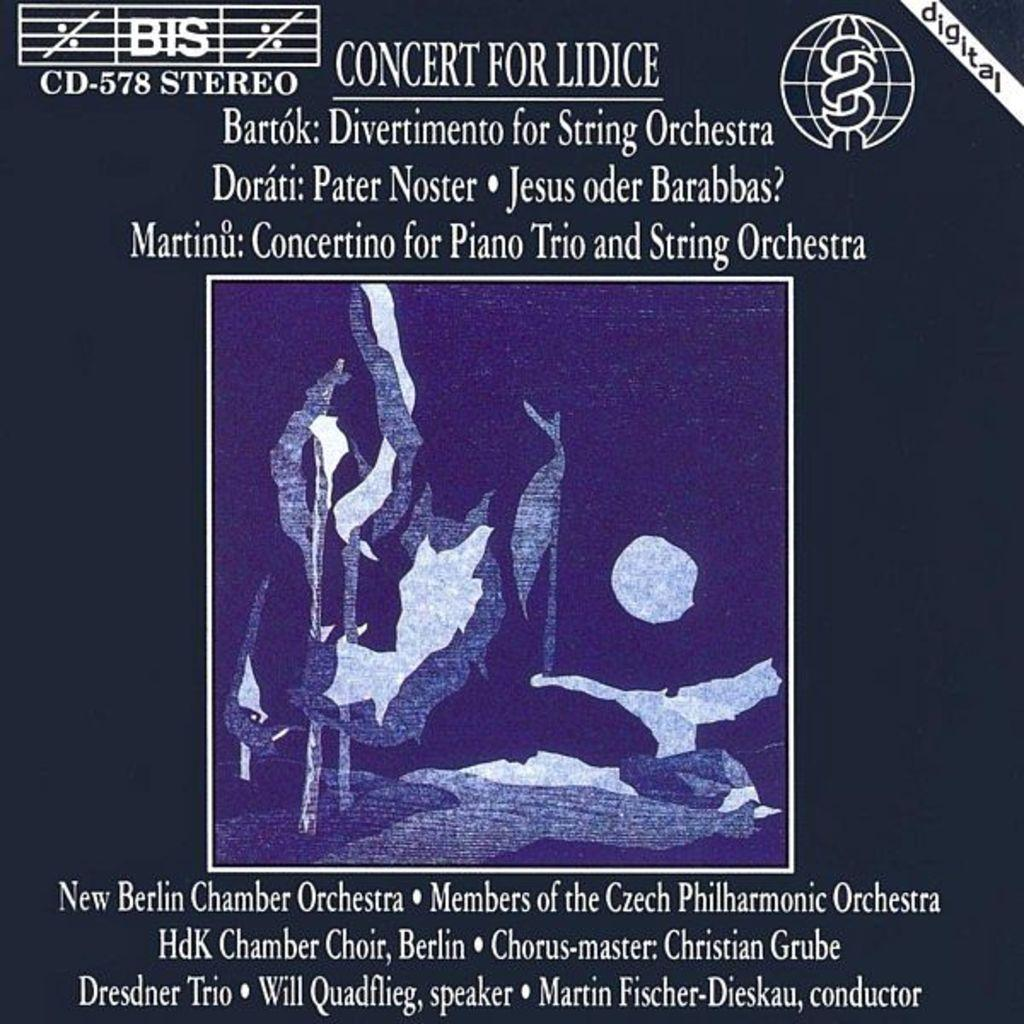<image>
Offer a succinct explanation of the picture presented. A concert music cover for Lidice which includes the New Berlin Chamber Orchestra. 